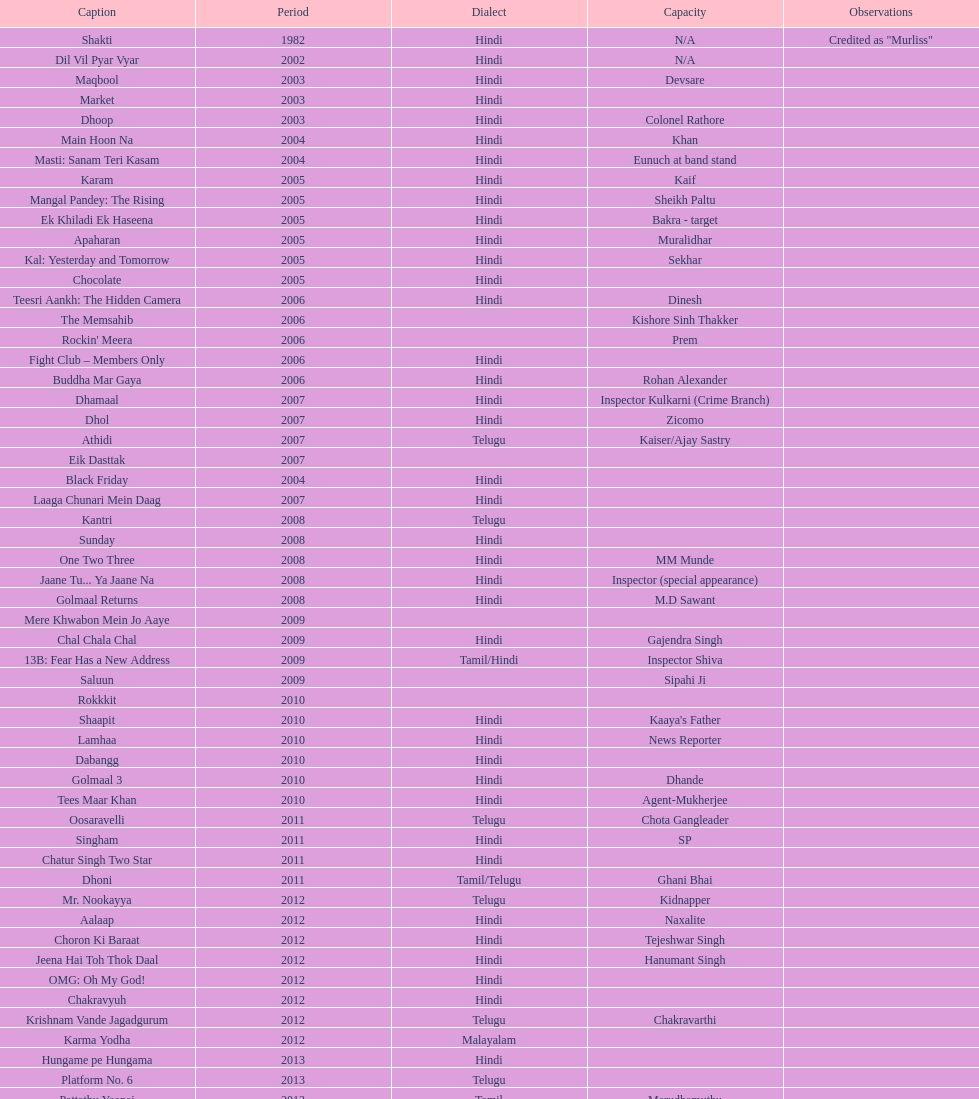What was the last malayalam film this actor starred in? Karma Yodha. 